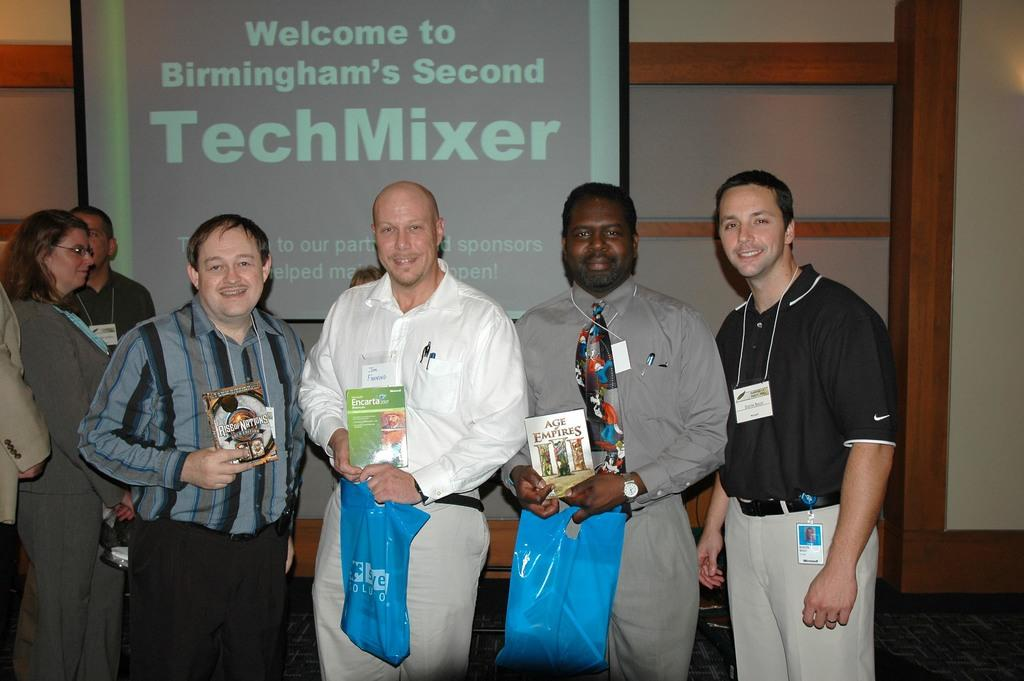What is happening in the image involving a group of people? In the image, there is a group of people standing and smiling. What are some of the people holding in the image? Some people are holding books and plastic covers. What can be seen in the background of the image? The background of the image includes a screen. What type of grape is being grown in the garden visible in the image? There is no garden or grape visible in the image. The background of the image includes a screen. 